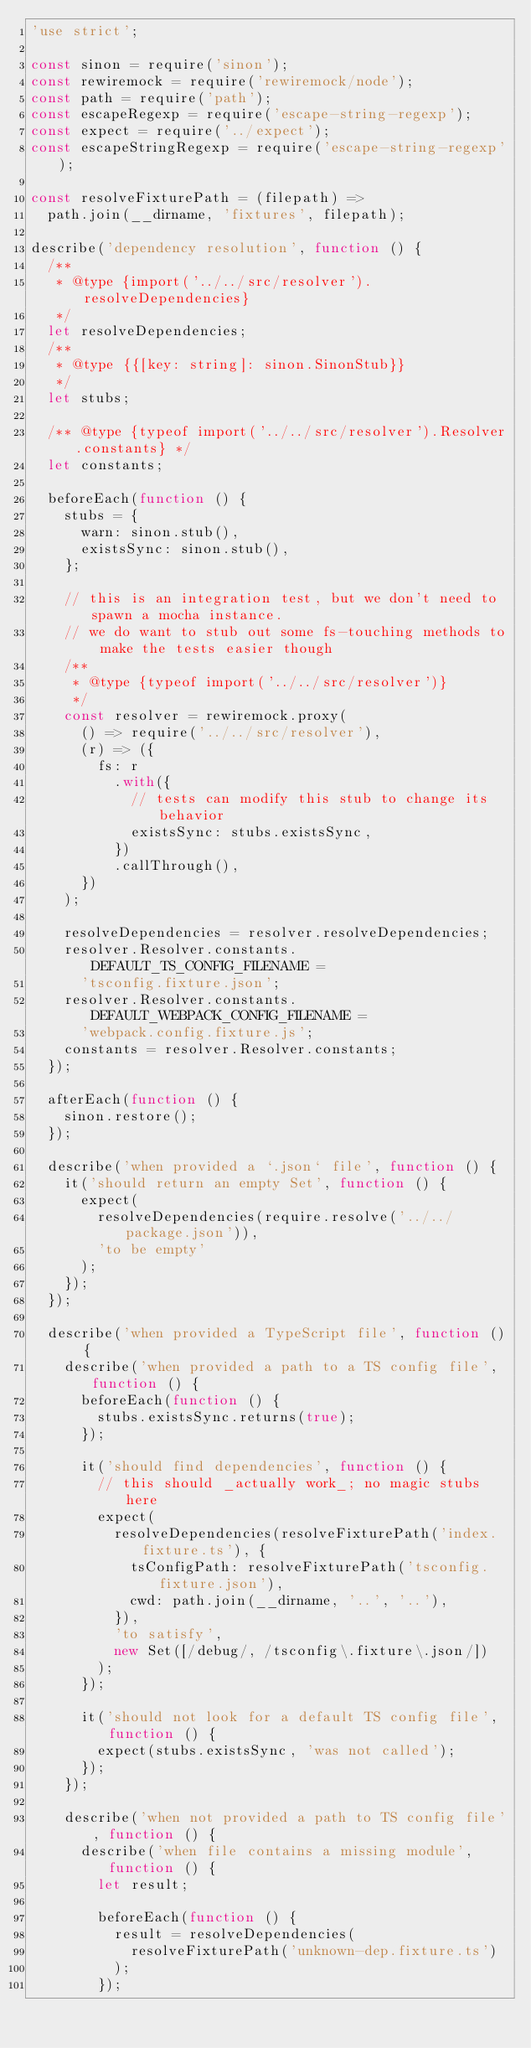Convert code to text. <code><loc_0><loc_0><loc_500><loc_500><_JavaScript_>'use strict';

const sinon = require('sinon');
const rewiremock = require('rewiremock/node');
const path = require('path');
const escapeRegexp = require('escape-string-regexp');
const expect = require('../expect');
const escapeStringRegexp = require('escape-string-regexp');

const resolveFixturePath = (filepath) =>
  path.join(__dirname, 'fixtures', filepath);

describe('dependency resolution', function () {
  /**
   * @type {import('../../src/resolver').resolveDependencies}
   */
  let resolveDependencies;
  /**
   * @type {{[key: string]: sinon.SinonStub}}
   */
  let stubs;

  /** @type {typeof import('../../src/resolver').Resolver.constants} */
  let constants;

  beforeEach(function () {
    stubs = {
      warn: sinon.stub(),
      existsSync: sinon.stub(),
    };

    // this is an integration test, but we don't need to spawn a mocha instance.
    // we do want to stub out some fs-touching methods to make the tests easier though
    /**
     * @type {typeof import('../../src/resolver')}
     */
    const resolver = rewiremock.proxy(
      () => require('../../src/resolver'),
      (r) => ({
        fs: r
          .with({
            // tests can modify this stub to change its behavior
            existsSync: stubs.existsSync,
          })
          .callThrough(),
      })
    );

    resolveDependencies = resolver.resolveDependencies;
    resolver.Resolver.constants.DEFAULT_TS_CONFIG_FILENAME =
      'tsconfig.fixture.json';
    resolver.Resolver.constants.DEFAULT_WEBPACK_CONFIG_FILENAME =
      'webpack.config.fixture.js';
    constants = resolver.Resolver.constants;
  });

  afterEach(function () {
    sinon.restore();
  });

  describe('when provided a `.json` file', function () {
    it('should return an empty Set', function () {
      expect(
        resolveDependencies(require.resolve('../../package.json')),
        'to be empty'
      );
    });
  });

  describe('when provided a TypeScript file', function () {
    describe('when provided a path to a TS config file', function () {
      beforeEach(function () {
        stubs.existsSync.returns(true);
      });

      it('should find dependencies', function () {
        // this should _actually work_; no magic stubs here
        expect(
          resolveDependencies(resolveFixturePath('index.fixture.ts'), {
            tsConfigPath: resolveFixturePath('tsconfig.fixture.json'),
            cwd: path.join(__dirname, '..', '..'),
          }),
          'to satisfy',
          new Set([/debug/, /tsconfig\.fixture\.json/])
        );
      });

      it('should not look for a default TS config file', function () {
        expect(stubs.existsSync, 'was not called');
      });
    });

    describe('when not provided a path to TS config file', function () {
      describe('when file contains a missing module', function () {
        let result;

        beforeEach(function () {
          result = resolveDependencies(
            resolveFixturePath('unknown-dep.fixture.ts')
          );
        });
</code> 